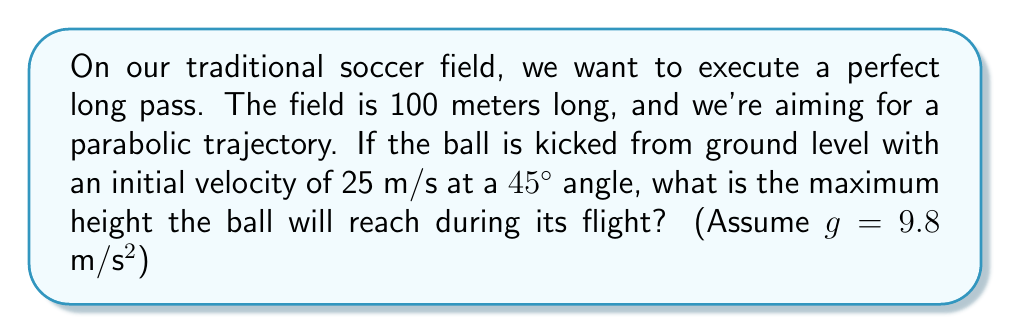What is the answer to this math problem? Let's approach this step-by-step, using the principles of projectile motion:

1) The trajectory of the ball follows a parabolic path, described by the equation:

   $$y = x \tan \theta - \frac{gx^2}{2v_0^2 \cos^2 \theta}$$

   where $y$ is the height, $x$ is the horizontal distance, $\theta$ is the launch angle, $v_0$ is the initial velocity, and $g$ is the acceleration due to gravity.

2) The maximum height occurs at the vertex of the parabola. To find this, we need to determine when $\frac{dy}{dx} = 0$.

3) Taking the derivative of the trajectory equation:

   $$\frac{dy}{dx} = \tan \theta - \frac{gx}{v_0^2 \cos^2 \theta}$$

4) Setting this equal to zero and solving for $x$:

   $$\tan \theta - \frac{gx}{v_0^2 \cos^2 \theta} = 0$$
   $$\frac{gx}{v_0^2 \cos^2 \theta} = \tan \theta$$
   $$x = \frac{v_0^2 \sin \theta \cos \theta}{g}$$

5) We're given that $\theta = 45°$, $v_0 = 25$ m/s, and $g = 9.8$ m/s². Also, $\sin 45° = \cos 45° = \frac{1}{\sqrt{2}}$. Substituting these values:

   $$x = \frac{25^2 \cdot \frac{1}{\sqrt{2}} \cdot \frac{1}{\sqrt{2}}}{9.8} \approx 31.89 \text{ m}$$

6) To find the maximum height, we substitute this $x$ value back into the original equation:

   $$y_{max} = 31.89 \tan 45° - \frac{9.8 \cdot 31.89^2}{2 \cdot 25^2 \cos^2 45°}$$
   $$y_{max} = 31.89 - \frac{9.8 \cdot 31.89^2}{2 \cdot 25^2 \cdot 0.5}$$
   $$y_{max} \approx 15.95 \text{ m}$$

Therefore, the maximum height the ball will reach is approximately 15.95 meters.
Answer: 15.95 m 